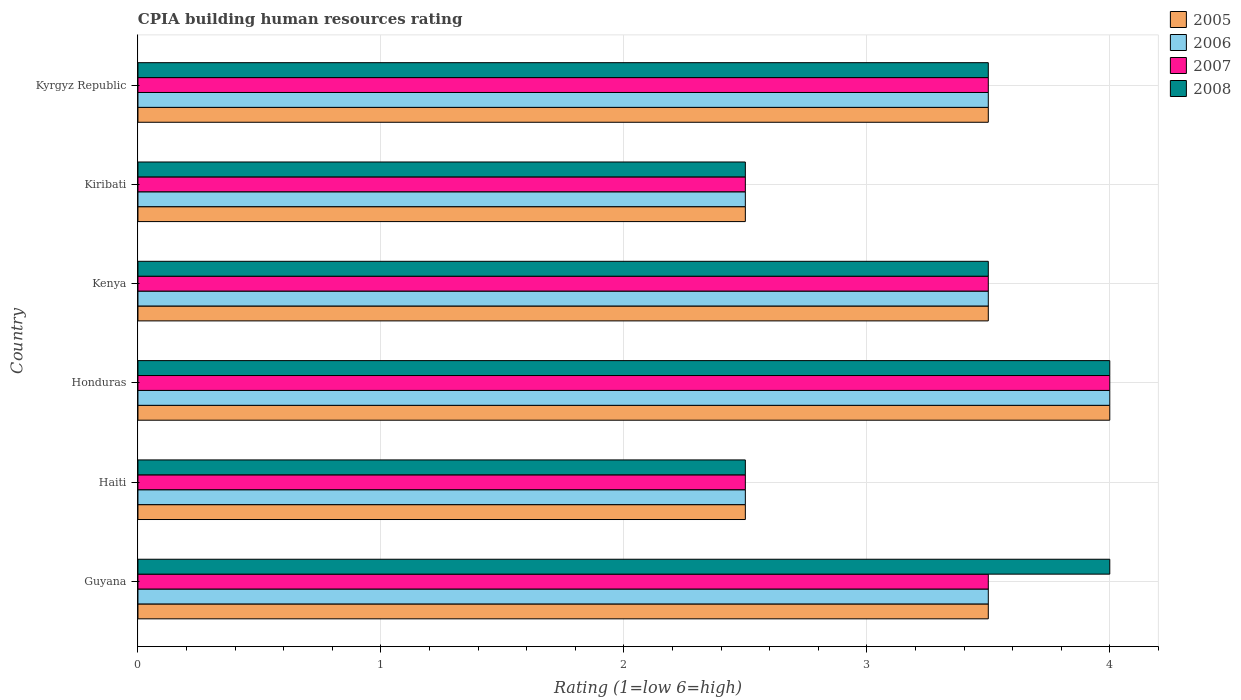How many different coloured bars are there?
Make the answer very short. 4. How many groups of bars are there?
Provide a succinct answer. 6. Are the number of bars on each tick of the Y-axis equal?
Your answer should be very brief. Yes. How many bars are there on the 4th tick from the bottom?
Make the answer very short. 4. What is the label of the 6th group of bars from the top?
Offer a terse response. Guyana. Across all countries, what is the maximum CPIA rating in 2005?
Keep it short and to the point. 4. In which country was the CPIA rating in 2008 maximum?
Make the answer very short. Guyana. In which country was the CPIA rating in 2008 minimum?
Provide a succinct answer. Haiti. What is the difference between the CPIA rating in 2007 in Haiti and that in Kenya?
Keep it short and to the point. -1. What is the average CPIA rating in 2008 per country?
Your answer should be compact. 3.33. What is the ratio of the CPIA rating in 2007 in Guyana to that in Kenya?
Keep it short and to the point. 1. Is the difference between the CPIA rating in 2006 in Guyana and Honduras greater than the difference between the CPIA rating in 2008 in Guyana and Honduras?
Make the answer very short. No. In how many countries, is the CPIA rating in 2007 greater than the average CPIA rating in 2007 taken over all countries?
Make the answer very short. 4. Is the sum of the CPIA rating in 2006 in Haiti and Kenya greater than the maximum CPIA rating in 2005 across all countries?
Keep it short and to the point. Yes. What does the 4th bar from the bottom in Kyrgyz Republic represents?
Your response must be concise. 2008. Is it the case that in every country, the sum of the CPIA rating in 2005 and CPIA rating in 2007 is greater than the CPIA rating in 2006?
Provide a short and direct response. Yes. How many bars are there?
Make the answer very short. 24. Are all the bars in the graph horizontal?
Keep it short and to the point. Yes. What is the difference between two consecutive major ticks on the X-axis?
Offer a terse response. 1. Does the graph contain any zero values?
Your answer should be very brief. No. How many legend labels are there?
Give a very brief answer. 4. What is the title of the graph?
Keep it short and to the point. CPIA building human resources rating. Does "2003" appear as one of the legend labels in the graph?
Your response must be concise. No. What is the label or title of the X-axis?
Provide a short and direct response. Rating (1=low 6=high). What is the Rating (1=low 6=high) of 2005 in Guyana?
Provide a succinct answer. 3.5. What is the Rating (1=low 6=high) in 2006 in Guyana?
Give a very brief answer. 3.5. What is the Rating (1=low 6=high) in 2008 in Guyana?
Give a very brief answer. 4. What is the Rating (1=low 6=high) in 2005 in Haiti?
Offer a very short reply. 2.5. What is the Rating (1=low 6=high) in 2006 in Haiti?
Your answer should be very brief. 2.5. What is the Rating (1=low 6=high) of 2007 in Honduras?
Keep it short and to the point. 4. What is the Rating (1=low 6=high) in 2008 in Honduras?
Provide a short and direct response. 4. What is the Rating (1=low 6=high) of 2005 in Kenya?
Ensure brevity in your answer.  3.5. What is the Rating (1=low 6=high) in 2007 in Kenya?
Offer a very short reply. 3.5. What is the Rating (1=low 6=high) in 2005 in Kiribati?
Your response must be concise. 2.5. What is the Rating (1=low 6=high) of 2006 in Kiribati?
Ensure brevity in your answer.  2.5. What is the Rating (1=low 6=high) of 2008 in Kiribati?
Offer a very short reply. 2.5. What is the Rating (1=low 6=high) of 2005 in Kyrgyz Republic?
Your answer should be very brief. 3.5. Across all countries, what is the maximum Rating (1=low 6=high) in 2006?
Offer a terse response. 4. Across all countries, what is the minimum Rating (1=low 6=high) in 2005?
Offer a terse response. 2.5. Across all countries, what is the minimum Rating (1=low 6=high) of 2008?
Ensure brevity in your answer.  2.5. What is the total Rating (1=low 6=high) of 2005 in the graph?
Give a very brief answer. 19.5. What is the total Rating (1=low 6=high) in 2006 in the graph?
Provide a succinct answer. 19.5. What is the total Rating (1=low 6=high) of 2008 in the graph?
Your answer should be compact. 20. What is the difference between the Rating (1=low 6=high) of 2008 in Guyana and that in Honduras?
Provide a succinct answer. 0. What is the difference between the Rating (1=low 6=high) in 2005 in Guyana and that in Kenya?
Keep it short and to the point. 0. What is the difference between the Rating (1=low 6=high) of 2006 in Guyana and that in Kenya?
Keep it short and to the point. 0. What is the difference between the Rating (1=low 6=high) in 2008 in Guyana and that in Kenya?
Provide a succinct answer. 0.5. What is the difference between the Rating (1=low 6=high) in 2005 in Guyana and that in Kiribati?
Give a very brief answer. 1. What is the difference between the Rating (1=low 6=high) in 2005 in Guyana and that in Kyrgyz Republic?
Your answer should be compact. 0. What is the difference between the Rating (1=low 6=high) in 2006 in Haiti and that in Honduras?
Make the answer very short. -1.5. What is the difference between the Rating (1=low 6=high) in 2007 in Haiti and that in Honduras?
Your answer should be very brief. -1.5. What is the difference between the Rating (1=low 6=high) of 2008 in Haiti and that in Honduras?
Ensure brevity in your answer.  -1.5. What is the difference between the Rating (1=low 6=high) in 2006 in Haiti and that in Kenya?
Give a very brief answer. -1. What is the difference between the Rating (1=low 6=high) of 2005 in Haiti and that in Kiribati?
Offer a very short reply. 0. What is the difference between the Rating (1=low 6=high) in 2006 in Haiti and that in Kiribati?
Provide a short and direct response. 0. What is the difference between the Rating (1=low 6=high) of 2008 in Haiti and that in Kiribati?
Ensure brevity in your answer.  0. What is the difference between the Rating (1=low 6=high) in 2007 in Haiti and that in Kyrgyz Republic?
Your answer should be compact. -1. What is the difference between the Rating (1=low 6=high) in 2008 in Haiti and that in Kyrgyz Republic?
Provide a succinct answer. -1. What is the difference between the Rating (1=low 6=high) of 2005 in Honduras and that in Kenya?
Your answer should be very brief. 0.5. What is the difference between the Rating (1=low 6=high) in 2008 in Honduras and that in Kiribati?
Your answer should be very brief. 1.5. What is the difference between the Rating (1=low 6=high) of 2005 in Honduras and that in Kyrgyz Republic?
Offer a very short reply. 0.5. What is the difference between the Rating (1=low 6=high) of 2006 in Kenya and that in Kyrgyz Republic?
Offer a terse response. 0. What is the difference between the Rating (1=low 6=high) in 2008 in Kenya and that in Kyrgyz Republic?
Ensure brevity in your answer.  0. What is the difference between the Rating (1=low 6=high) of 2005 in Guyana and the Rating (1=low 6=high) of 2008 in Haiti?
Keep it short and to the point. 1. What is the difference between the Rating (1=low 6=high) in 2007 in Guyana and the Rating (1=low 6=high) in 2008 in Haiti?
Ensure brevity in your answer.  1. What is the difference between the Rating (1=low 6=high) in 2006 in Guyana and the Rating (1=low 6=high) in 2007 in Honduras?
Make the answer very short. -0.5. What is the difference between the Rating (1=low 6=high) of 2005 in Guyana and the Rating (1=low 6=high) of 2007 in Kenya?
Your answer should be compact. 0. What is the difference between the Rating (1=low 6=high) of 2006 in Guyana and the Rating (1=low 6=high) of 2008 in Kenya?
Keep it short and to the point. 0. What is the difference between the Rating (1=low 6=high) of 2005 in Guyana and the Rating (1=low 6=high) of 2008 in Kiribati?
Offer a terse response. 1. What is the difference between the Rating (1=low 6=high) in 2006 in Guyana and the Rating (1=low 6=high) in 2008 in Kiribati?
Your answer should be compact. 1. What is the difference between the Rating (1=low 6=high) of 2005 in Guyana and the Rating (1=low 6=high) of 2007 in Kyrgyz Republic?
Keep it short and to the point. 0. What is the difference between the Rating (1=low 6=high) of 2005 in Guyana and the Rating (1=low 6=high) of 2008 in Kyrgyz Republic?
Provide a short and direct response. 0. What is the difference between the Rating (1=low 6=high) of 2006 in Guyana and the Rating (1=low 6=high) of 2007 in Kyrgyz Republic?
Make the answer very short. 0. What is the difference between the Rating (1=low 6=high) in 2006 in Guyana and the Rating (1=low 6=high) in 2008 in Kyrgyz Republic?
Ensure brevity in your answer.  0. What is the difference between the Rating (1=low 6=high) in 2007 in Guyana and the Rating (1=low 6=high) in 2008 in Kyrgyz Republic?
Offer a terse response. 0. What is the difference between the Rating (1=low 6=high) in 2005 in Haiti and the Rating (1=low 6=high) in 2008 in Honduras?
Offer a terse response. -1.5. What is the difference between the Rating (1=low 6=high) in 2007 in Haiti and the Rating (1=low 6=high) in 2008 in Honduras?
Make the answer very short. -1.5. What is the difference between the Rating (1=low 6=high) in 2005 in Haiti and the Rating (1=low 6=high) in 2007 in Kenya?
Provide a short and direct response. -1. What is the difference between the Rating (1=low 6=high) in 2007 in Haiti and the Rating (1=low 6=high) in 2008 in Kenya?
Your answer should be very brief. -1. What is the difference between the Rating (1=low 6=high) of 2005 in Haiti and the Rating (1=low 6=high) of 2007 in Kiribati?
Your answer should be compact. 0. What is the difference between the Rating (1=low 6=high) in 2005 in Haiti and the Rating (1=low 6=high) in 2008 in Kiribati?
Make the answer very short. 0. What is the difference between the Rating (1=low 6=high) in 2006 in Haiti and the Rating (1=low 6=high) in 2008 in Kiribati?
Your answer should be compact. 0. What is the difference between the Rating (1=low 6=high) in 2006 in Haiti and the Rating (1=low 6=high) in 2007 in Kyrgyz Republic?
Your answer should be very brief. -1. What is the difference between the Rating (1=low 6=high) of 2005 in Honduras and the Rating (1=low 6=high) of 2007 in Kenya?
Your answer should be compact. 0.5. What is the difference between the Rating (1=low 6=high) in 2005 in Honduras and the Rating (1=low 6=high) in 2008 in Kenya?
Give a very brief answer. 0.5. What is the difference between the Rating (1=low 6=high) in 2006 in Honduras and the Rating (1=low 6=high) in 2007 in Kenya?
Provide a succinct answer. 0.5. What is the difference between the Rating (1=low 6=high) in 2006 in Honduras and the Rating (1=low 6=high) in 2008 in Kenya?
Your answer should be very brief. 0.5. What is the difference between the Rating (1=low 6=high) of 2005 in Honduras and the Rating (1=low 6=high) of 2006 in Kiribati?
Provide a succinct answer. 1.5. What is the difference between the Rating (1=low 6=high) of 2005 in Honduras and the Rating (1=low 6=high) of 2007 in Kiribati?
Give a very brief answer. 1.5. What is the difference between the Rating (1=low 6=high) of 2005 in Honduras and the Rating (1=low 6=high) of 2008 in Kiribati?
Your response must be concise. 1.5. What is the difference between the Rating (1=low 6=high) of 2006 in Honduras and the Rating (1=low 6=high) of 2007 in Kiribati?
Your response must be concise. 1.5. What is the difference between the Rating (1=low 6=high) in 2005 in Honduras and the Rating (1=low 6=high) in 2008 in Kyrgyz Republic?
Provide a succinct answer. 0.5. What is the difference between the Rating (1=low 6=high) in 2006 in Honduras and the Rating (1=low 6=high) in 2007 in Kyrgyz Republic?
Ensure brevity in your answer.  0.5. What is the difference between the Rating (1=low 6=high) in 2007 in Honduras and the Rating (1=low 6=high) in 2008 in Kyrgyz Republic?
Provide a succinct answer. 0.5. What is the difference between the Rating (1=low 6=high) in 2005 in Kenya and the Rating (1=low 6=high) in 2008 in Kiribati?
Provide a short and direct response. 1. What is the difference between the Rating (1=low 6=high) of 2007 in Kenya and the Rating (1=low 6=high) of 2008 in Kiribati?
Keep it short and to the point. 1. What is the difference between the Rating (1=low 6=high) in 2005 in Kenya and the Rating (1=low 6=high) in 2008 in Kyrgyz Republic?
Make the answer very short. 0. What is the difference between the Rating (1=low 6=high) of 2005 in Kiribati and the Rating (1=low 6=high) of 2008 in Kyrgyz Republic?
Ensure brevity in your answer.  -1. What is the difference between the Rating (1=low 6=high) in 2006 in Kiribati and the Rating (1=low 6=high) in 2008 in Kyrgyz Republic?
Your response must be concise. -1. What is the average Rating (1=low 6=high) of 2005 per country?
Ensure brevity in your answer.  3.25. What is the average Rating (1=low 6=high) in 2006 per country?
Ensure brevity in your answer.  3.25. What is the average Rating (1=low 6=high) of 2007 per country?
Provide a succinct answer. 3.25. What is the average Rating (1=low 6=high) of 2008 per country?
Provide a succinct answer. 3.33. What is the difference between the Rating (1=low 6=high) of 2005 and Rating (1=low 6=high) of 2007 in Guyana?
Offer a very short reply. 0. What is the difference between the Rating (1=low 6=high) in 2006 and Rating (1=low 6=high) in 2008 in Guyana?
Your response must be concise. -0.5. What is the difference between the Rating (1=low 6=high) of 2005 and Rating (1=low 6=high) of 2006 in Honduras?
Give a very brief answer. 0. What is the difference between the Rating (1=low 6=high) of 2005 and Rating (1=low 6=high) of 2008 in Honduras?
Offer a terse response. 0. What is the difference between the Rating (1=low 6=high) in 2006 and Rating (1=low 6=high) in 2008 in Honduras?
Ensure brevity in your answer.  0. What is the difference between the Rating (1=low 6=high) in 2007 and Rating (1=low 6=high) in 2008 in Honduras?
Give a very brief answer. 0. What is the difference between the Rating (1=low 6=high) of 2005 and Rating (1=low 6=high) of 2006 in Kenya?
Ensure brevity in your answer.  0. What is the difference between the Rating (1=low 6=high) of 2006 and Rating (1=low 6=high) of 2007 in Kenya?
Give a very brief answer. 0. What is the difference between the Rating (1=low 6=high) of 2007 and Rating (1=low 6=high) of 2008 in Kenya?
Provide a short and direct response. 0. What is the difference between the Rating (1=low 6=high) in 2005 and Rating (1=low 6=high) in 2006 in Kiribati?
Offer a very short reply. 0. What is the difference between the Rating (1=low 6=high) of 2006 and Rating (1=low 6=high) of 2007 in Kiribati?
Make the answer very short. 0. What is the difference between the Rating (1=low 6=high) of 2006 and Rating (1=low 6=high) of 2008 in Kiribati?
Your answer should be compact. 0. What is the difference between the Rating (1=low 6=high) in 2007 and Rating (1=low 6=high) in 2008 in Kiribati?
Your answer should be compact. 0. What is the difference between the Rating (1=low 6=high) in 2005 and Rating (1=low 6=high) in 2007 in Kyrgyz Republic?
Your answer should be compact. 0. What is the difference between the Rating (1=low 6=high) of 2006 and Rating (1=low 6=high) of 2007 in Kyrgyz Republic?
Offer a terse response. 0. What is the difference between the Rating (1=low 6=high) of 2007 and Rating (1=low 6=high) of 2008 in Kyrgyz Republic?
Your answer should be compact. 0. What is the ratio of the Rating (1=low 6=high) of 2005 in Guyana to that in Haiti?
Provide a short and direct response. 1.4. What is the ratio of the Rating (1=low 6=high) in 2007 in Guyana to that in Haiti?
Your answer should be compact. 1.4. What is the ratio of the Rating (1=low 6=high) of 2005 in Guyana to that in Honduras?
Give a very brief answer. 0.88. What is the ratio of the Rating (1=low 6=high) of 2006 in Guyana to that in Honduras?
Keep it short and to the point. 0.88. What is the ratio of the Rating (1=low 6=high) in 2008 in Guyana to that in Honduras?
Your answer should be compact. 1. What is the ratio of the Rating (1=low 6=high) in 2005 in Guyana to that in Kenya?
Your answer should be compact. 1. What is the ratio of the Rating (1=low 6=high) in 2006 in Guyana to that in Kenya?
Keep it short and to the point. 1. What is the ratio of the Rating (1=low 6=high) of 2005 in Guyana to that in Kiribati?
Offer a terse response. 1.4. What is the ratio of the Rating (1=low 6=high) in 2007 in Guyana to that in Kiribati?
Provide a succinct answer. 1.4. What is the ratio of the Rating (1=low 6=high) in 2008 in Guyana to that in Kiribati?
Your answer should be very brief. 1.6. What is the ratio of the Rating (1=low 6=high) of 2005 in Guyana to that in Kyrgyz Republic?
Give a very brief answer. 1. What is the ratio of the Rating (1=low 6=high) in 2007 in Guyana to that in Kyrgyz Republic?
Keep it short and to the point. 1. What is the ratio of the Rating (1=low 6=high) in 2005 in Haiti to that in Honduras?
Ensure brevity in your answer.  0.62. What is the ratio of the Rating (1=low 6=high) of 2007 in Haiti to that in Honduras?
Give a very brief answer. 0.62. What is the ratio of the Rating (1=low 6=high) of 2006 in Haiti to that in Kenya?
Offer a very short reply. 0.71. What is the ratio of the Rating (1=low 6=high) in 2007 in Haiti to that in Kenya?
Provide a short and direct response. 0.71. What is the ratio of the Rating (1=low 6=high) in 2008 in Haiti to that in Kenya?
Offer a very short reply. 0.71. What is the ratio of the Rating (1=low 6=high) of 2005 in Haiti to that in Kiribati?
Your answer should be compact. 1. What is the ratio of the Rating (1=low 6=high) in 2006 in Haiti to that in Kiribati?
Offer a very short reply. 1. What is the ratio of the Rating (1=low 6=high) of 2005 in Haiti to that in Kyrgyz Republic?
Give a very brief answer. 0.71. What is the ratio of the Rating (1=low 6=high) in 2008 in Haiti to that in Kyrgyz Republic?
Give a very brief answer. 0.71. What is the ratio of the Rating (1=low 6=high) in 2005 in Honduras to that in Kenya?
Provide a succinct answer. 1.14. What is the ratio of the Rating (1=low 6=high) of 2006 in Honduras to that in Kenya?
Provide a succinct answer. 1.14. What is the ratio of the Rating (1=low 6=high) in 2007 in Honduras to that in Kenya?
Make the answer very short. 1.14. What is the ratio of the Rating (1=low 6=high) of 2006 in Honduras to that in Kiribati?
Give a very brief answer. 1.6. What is the ratio of the Rating (1=low 6=high) of 2007 in Honduras to that in Kiribati?
Offer a very short reply. 1.6. What is the ratio of the Rating (1=low 6=high) in 2008 in Honduras to that in Kiribati?
Offer a very short reply. 1.6. What is the ratio of the Rating (1=low 6=high) in 2005 in Honduras to that in Kyrgyz Republic?
Give a very brief answer. 1.14. What is the ratio of the Rating (1=low 6=high) of 2006 in Honduras to that in Kyrgyz Republic?
Provide a short and direct response. 1.14. What is the ratio of the Rating (1=low 6=high) of 2008 in Honduras to that in Kyrgyz Republic?
Your answer should be very brief. 1.14. What is the ratio of the Rating (1=low 6=high) in 2005 in Kenya to that in Kiribati?
Provide a short and direct response. 1.4. What is the ratio of the Rating (1=low 6=high) in 2007 in Kenya to that in Kiribati?
Ensure brevity in your answer.  1.4. What is the ratio of the Rating (1=low 6=high) in 2008 in Kenya to that in Kiribati?
Offer a very short reply. 1.4. What is the ratio of the Rating (1=low 6=high) of 2005 in Kenya to that in Kyrgyz Republic?
Offer a terse response. 1. What is the ratio of the Rating (1=low 6=high) of 2006 in Kenya to that in Kyrgyz Republic?
Keep it short and to the point. 1. What is the ratio of the Rating (1=low 6=high) of 2007 in Kenya to that in Kyrgyz Republic?
Your answer should be very brief. 1. What is the ratio of the Rating (1=low 6=high) of 2007 in Kiribati to that in Kyrgyz Republic?
Keep it short and to the point. 0.71. What is the difference between the highest and the second highest Rating (1=low 6=high) of 2008?
Ensure brevity in your answer.  0. What is the difference between the highest and the lowest Rating (1=low 6=high) of 2006?
Give a very brief answer. 1.5. 